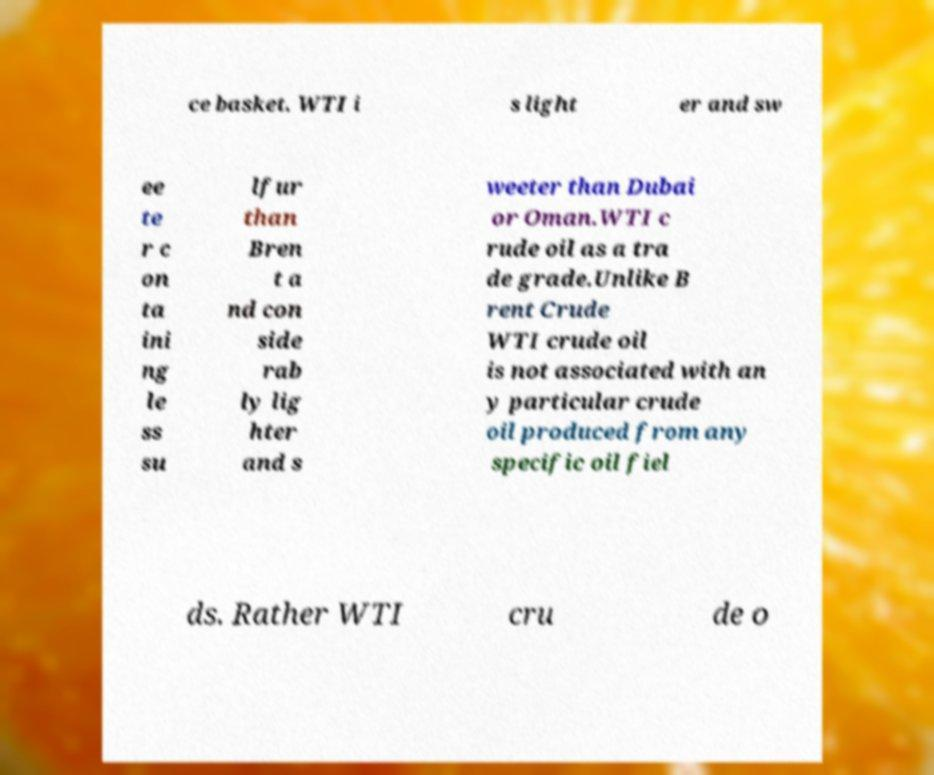Could you assist in decoding the text presented in this image and type it out clearly? ce basket. WTI i s light er and sw ee te r c on ta ini ng le ss su lfur than Bren t a nd con side rab ly lig hter and s weeter than Dubai or Oman.WTI c rude oil as a tra de grade.Unlike B rent Crude WTI crude oil is not associated with an y particular crude oil produced from any specific oil fiel ds. Rather WTI cru de o 